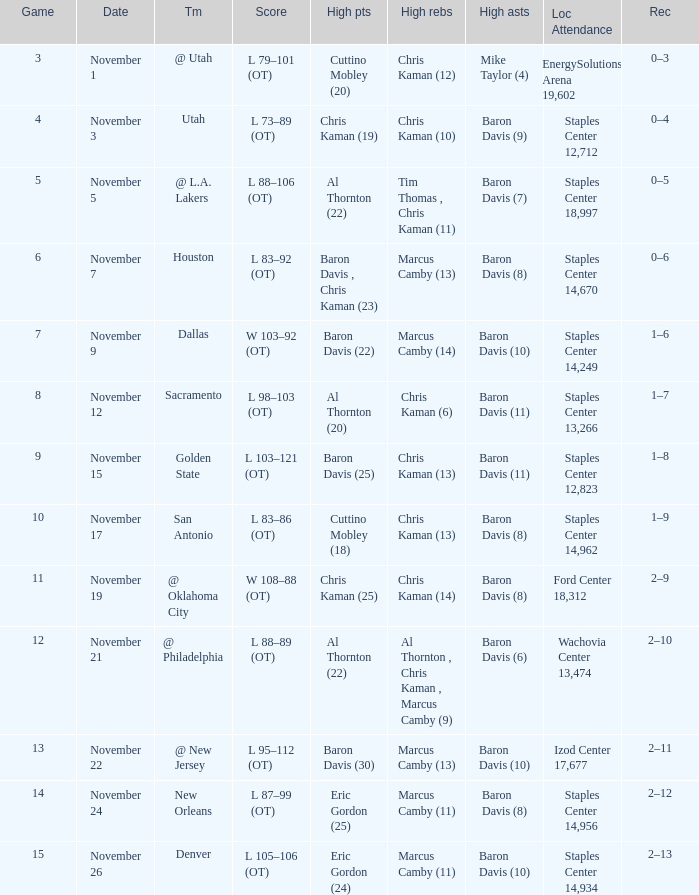Name the high points for the date of november 24 Eric Gordon (25). Could you parse the entire table as a dict? {'header': ['Game', 'Date', 'Tm', 'Score', 'High pts', 'High rebs', 'High asts', 'Loc Attendance', 'Rec'], 'rows': [['3', 'November 1', '@ Utah', 'L 79–101 (OT)', 'Cuttino Mobley (20)', 'Chris Kaman (12)', 'Mike Taylor (4)', 'EnergySolutions Arena 19,602', '0–3'], ['4', 'November 3', 'Utah', 'L 73–89 (OT)', 'Chris Kaman (19)', 'Chris Kaman (10)', 'Baron Davis (9)', 'Staples Center 12,712', '0–4'], ['5', 'November 5', '@ L.A. Lakers', 'L 88–106 (OT)', 'Al Thornton (22)', 'Tim Thomas , Chris Kaman (11)', 'Baron Davis (7)', 'Staples Center 18,997', '0–5'], ['6', 'November 7', 'Houston', 'L 83–92 (OT)', 'Baron Davis , Chris Kaman (23)', 'Marcus Camby (13)', 'Baron Davis (8)', 'Staples Center 14,670', '0–6'], ['7', 'November 9', 'Dallas', 'W 103–92 (OT)', 'Baron Davis (22)', 'Marcus Camby (14)', 'Baron Davis (10)', 'Staples Center 14,249', '1–6'], ['8', 'November 12', 'Sacramento', 'L 98–103 (OT)', 'Al Thornton (20)', 'Chris Kaman (6)', 'Baron Davis (11)', 'Staples Center 13,266', '1–7'], ['9', 'November 15', 'Golden State', 'L 103–121 (OT)', 'Baron Davis (25)', 'Chris Kaman (13)', 'Baron Davis (11)', 'Staples Center 12,823', '1–8'], ['10', 'November 17', 'San Antonio', 'L 83–86 (OT)', 'Cuttino Mobley (18)', 'Chris Kaman (13)', 'Baron Davis (8)', 'Staples Center 14,962', '1–9'], ['11', 'November 19', '@ Oklahoma City', 'W 108–88 (OT)', 'Chris Kaman (25)', 'Chris Kaman (14)', 'Baron Davis (8)', 'Ford Center 18,312', '2–9'], ['12', 'November 21', '@ Philadelphia', 'L 88–89 (OT)', 'Al Thornton (22)', 'Al Thornton , Chris Kaman , Marcus Camby (9)', 'Baron Davis (6)', 'Wachovia Center 13,474', '2–10'], ['13', 'November 22', '@ New Jersey', 'L 95–112 (OT)', 'Baron Davis (30)', 'Marcus Camby (13)', 'Baron Davis (10)', 'Izod Center 17,677', '2–11'], ['14', 'November 24', 'New Orleans', 'L 87–99 (OT)', 'Eric Gordon (25)', 'Marcus Camby (11)', 'Baron Davis (8)', 'Staples Center 14,956', '2–12'], ['15', 'November 26', 'Denver', 'L 105–106 (OT)', 'Eric Gordon (24)', 'Marcus Camby (11)', 'Baron Davis (10)', 'Staples Center 14,934', '2–13']]} 